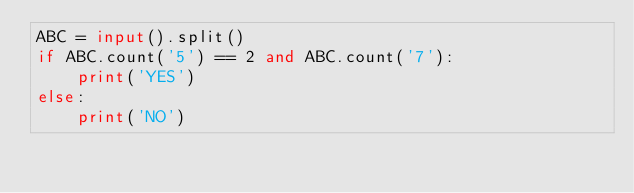Convert code to text. <code><loc_0><loc_0><loc_500><loc_500><_Python_>ABC = input().split()
if ABC.count('5') == 2 and ABC.count('7'):
    print('YES')
else:
    print('NO')</code> 